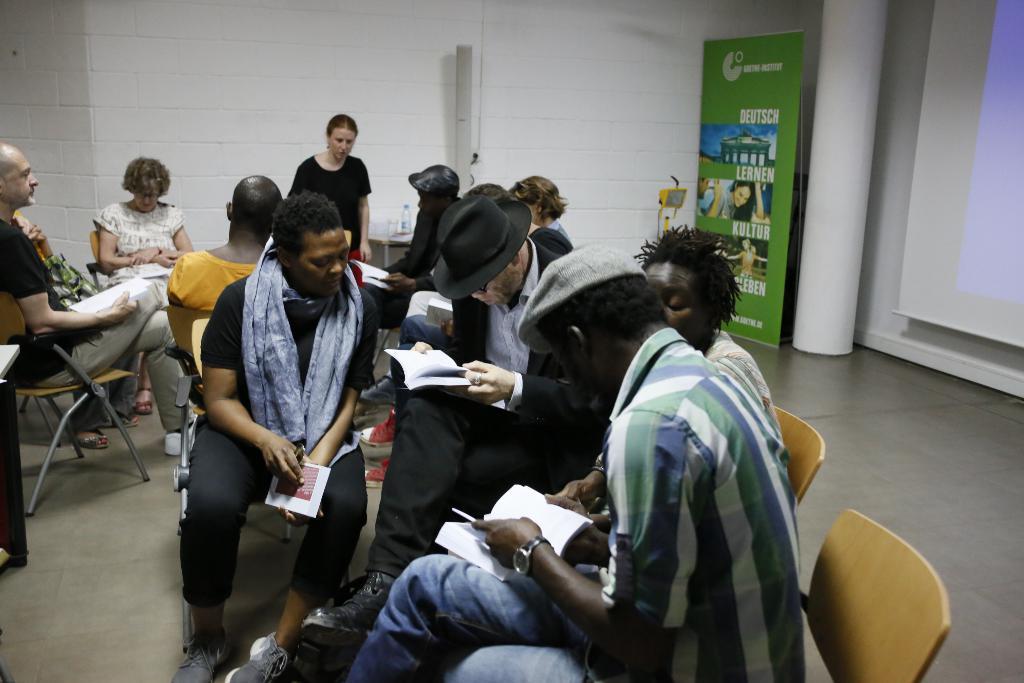Please provide a concise description of this image. In this image there are group of persons who are sitting on the chairs in a room. 